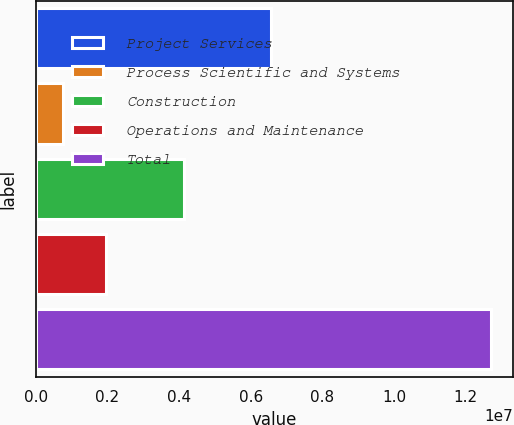<chart> <loc_0><loc_0><loc_500><loc_500><bar_chart><fcel>Project Services<fcel>Process Scientific and Systems<fcel>Construction<fcel>Operations and Maintenance<fcel>Total<nl><fcel>6.576e+06<fcel>758957<fcel>4.13873e+06<fcel>1.95258e+06<fcel>1.26952e+07<nl></chart> 